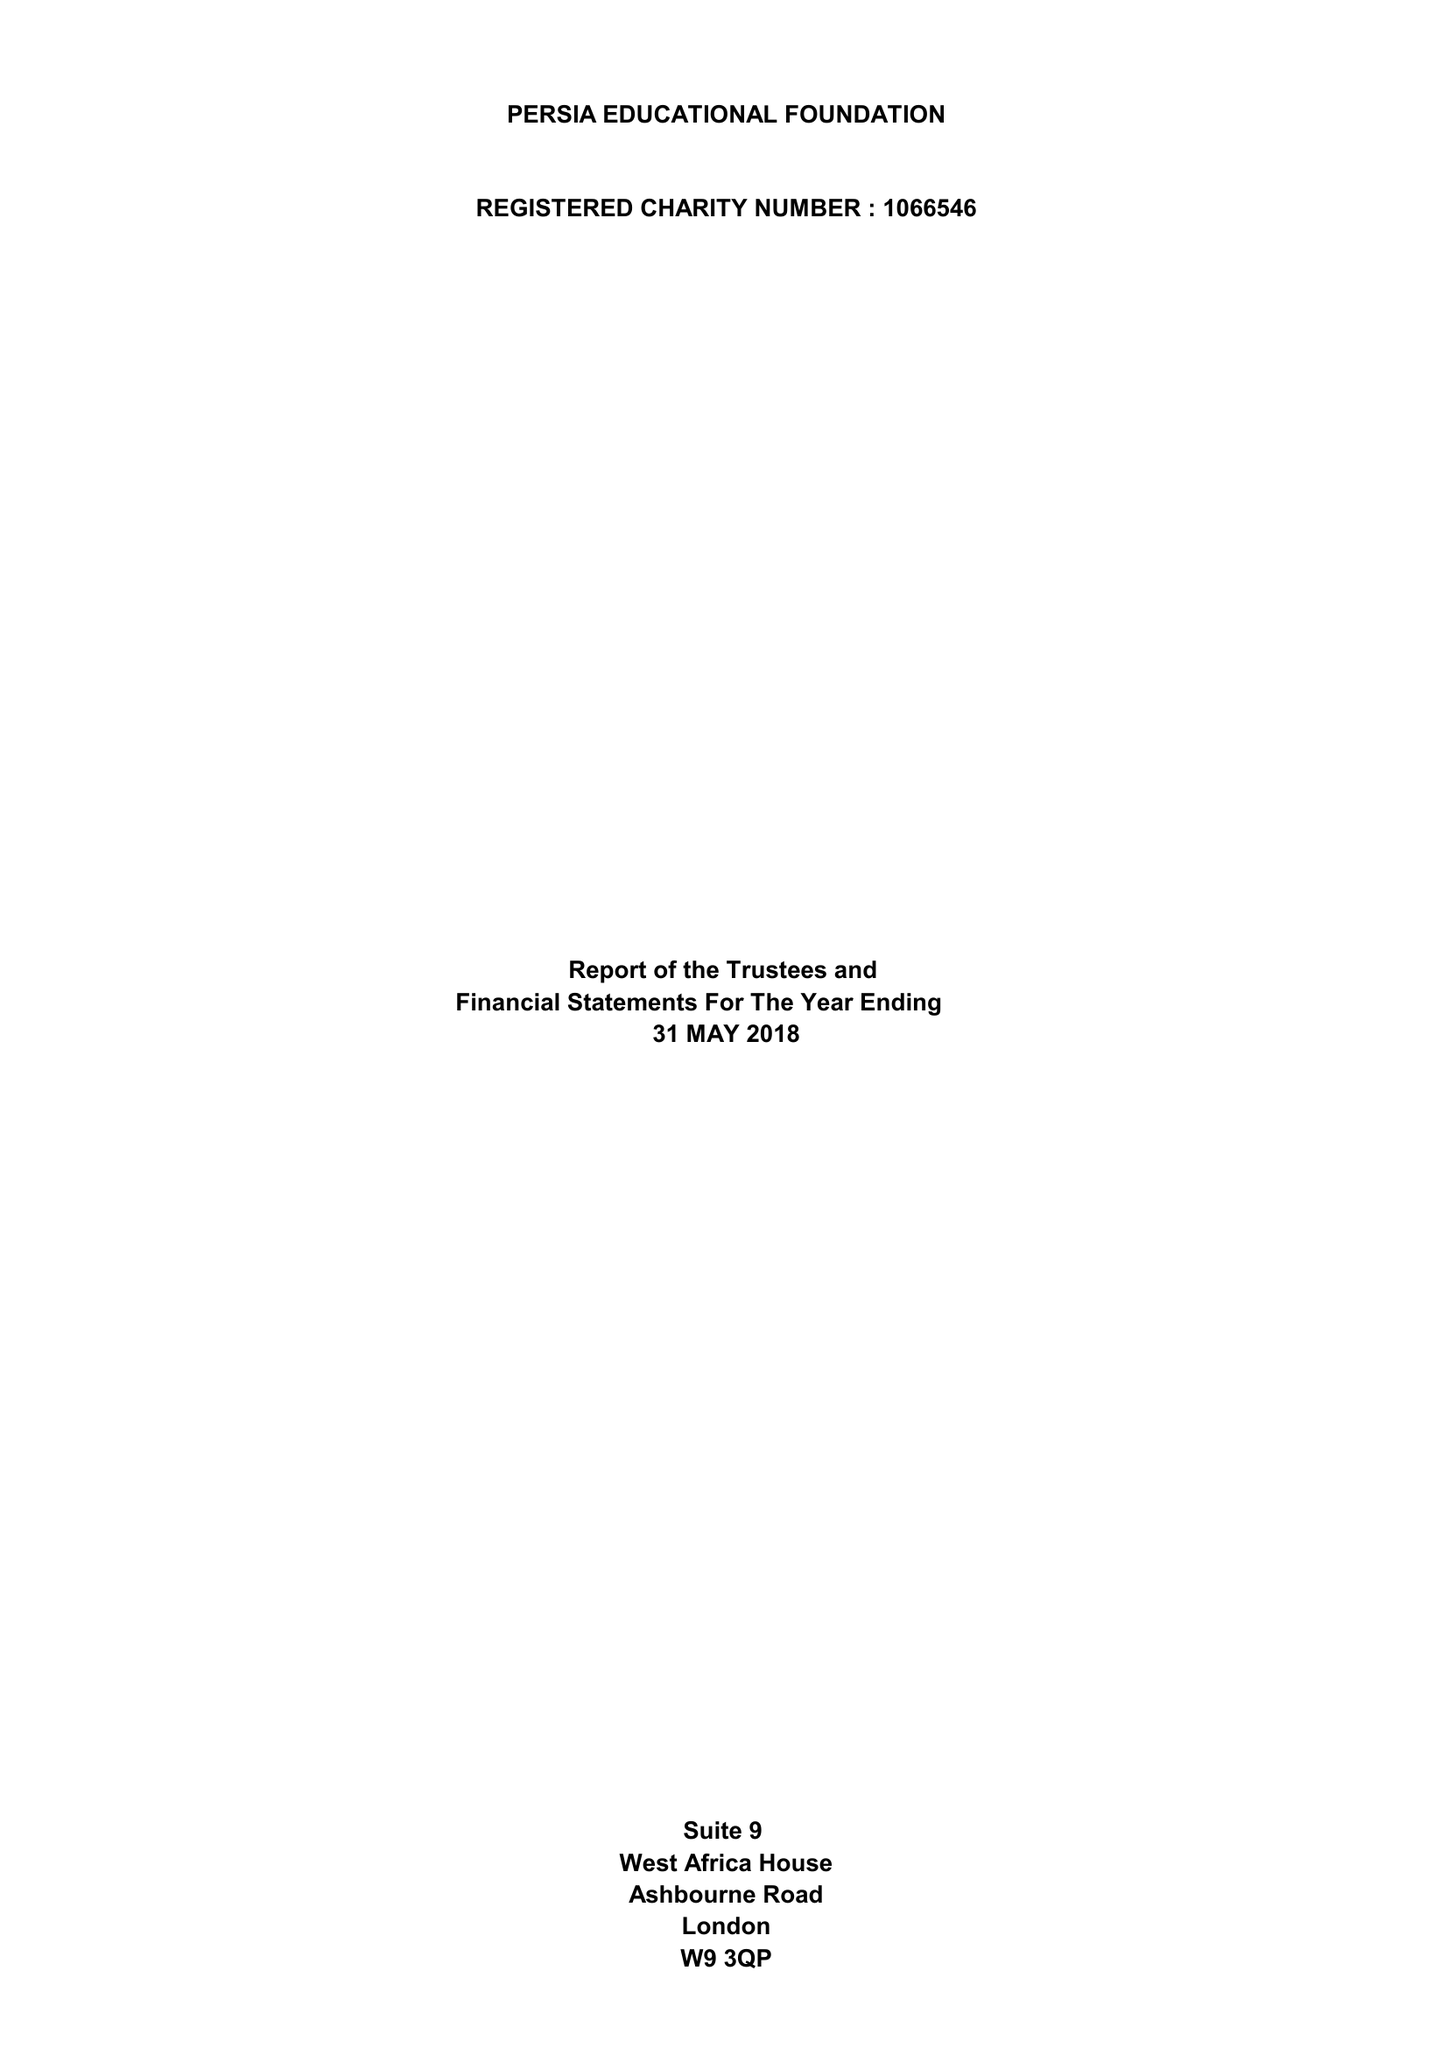What is the value for the address__street_line?
Answer the question using a single word or phrase. ASHBOURNE ROAD 